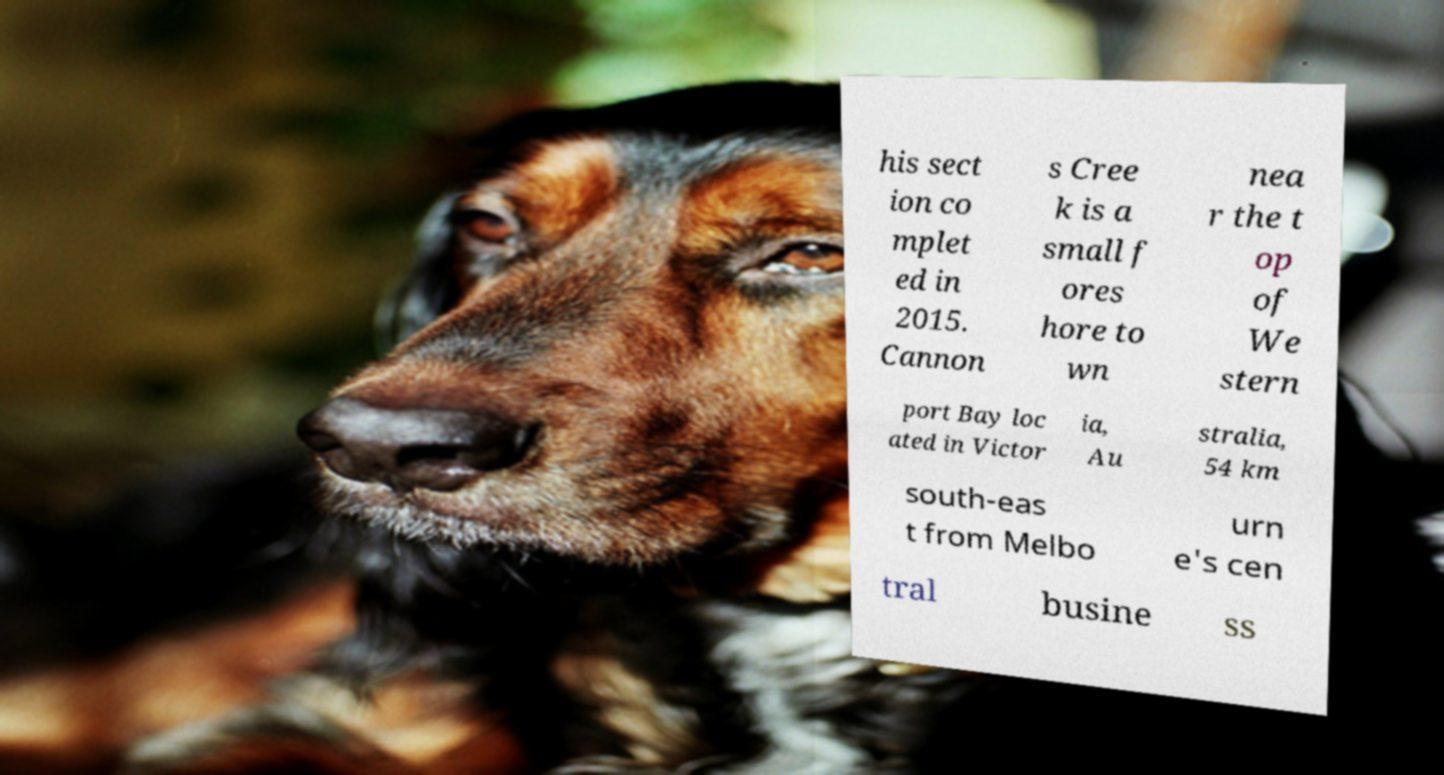Please read and relay the text visible in this image. What does it say? his sect ion co mplet ed in 2015. Cannon s Cree k is a small f ores hore to wn nea r the t op of We stern port Bay loc ated in Victor ia, Au stralia, 54 km south-eas t from Melbo urn e's cen tral busine ss 